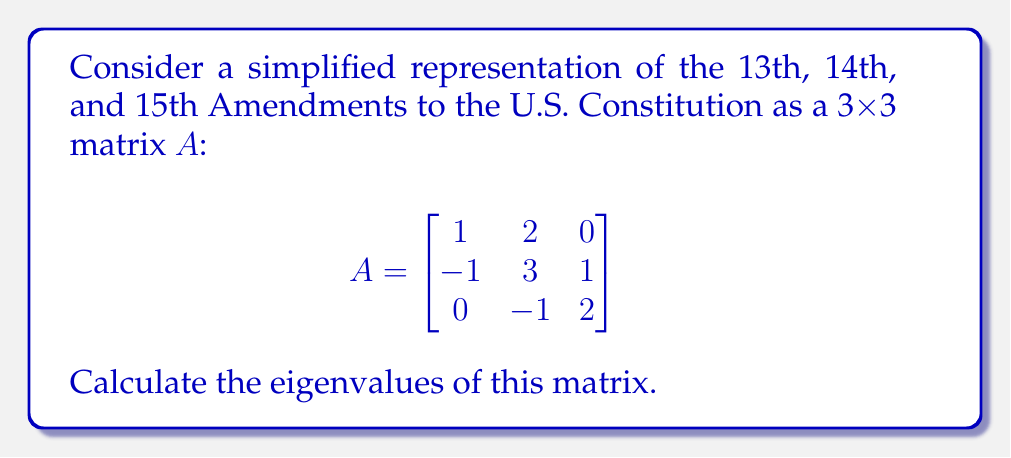Help me with this question. To find the eigenvalues of matrix A, we need to solve the characteristic equation:

1. Calculate det(A - λI), where I is the 3x3 identity matrix:

   $$\det(A - λI) = \det\begin{bmatrix}
   1-λ & 2 & 0 \\
   -1 & 3-λ & 1 \\
   0 & -1 & 2-λ
   \end{bmatrix}$$

2. Expand the determinant:
   $$(1-λ)[(3-λ)(2-λ) - 1] - 2[-1(2-λ) - 0] + 0$$
   $$= (1-λ)(6-5λ+λ^2-1) + 2(2-λ)$$
   $$= (1-λ)(5-5λ+λ^2) + 4-2λ$$
   $$= 5-5λ+λ^2-5λ+5λ^2-λ^3+4-2λ$$
   $$= -λ^3+6λ^2-12λ+9$$

3. Set the characteristic polynomial equal to zero:
   $$-λ^3+6λ^2-12λ+9 = 0$$

4. Factor the polynomial:
   $$(λ-1)(λ-2)(λ-3) = 0$$

5. Solve for λ:
   The eigenvalues are the roots of this equation: λ = 1, 2, and 3.
Answer: The eigenvalues are 1, 2, and 3. 